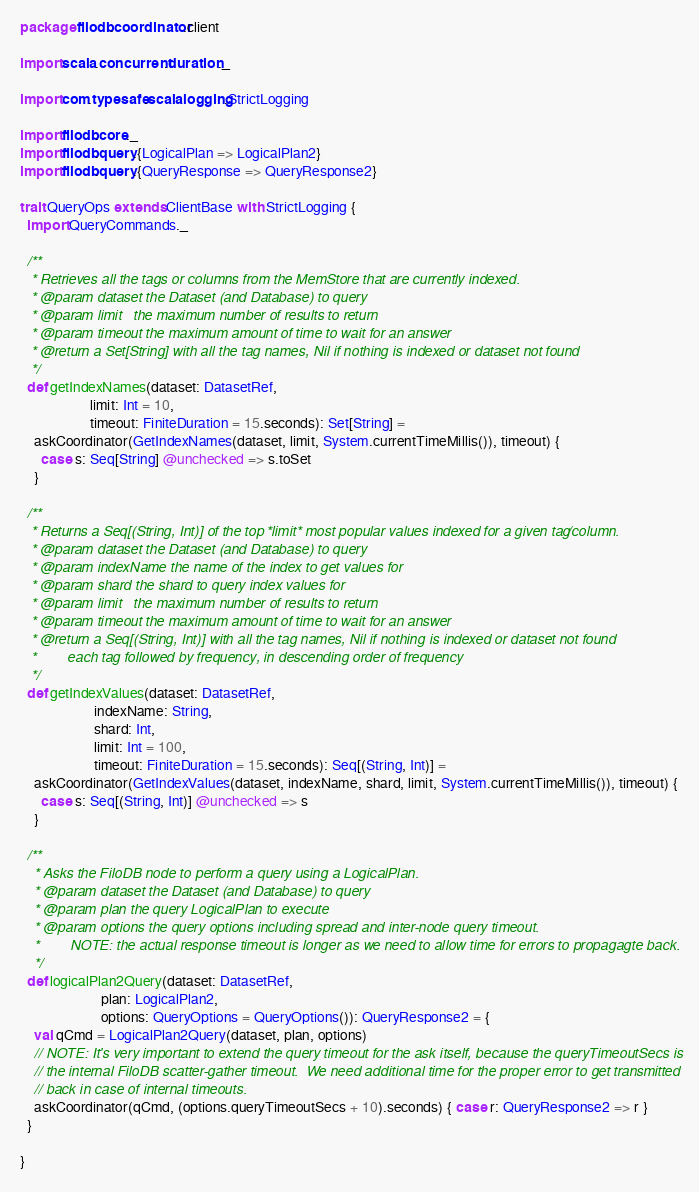Convert code to text. <code><loc_0><loc_0><loc_500><loc_500><_Scala_>package filodb.coordinator.client

import scala.concurrent.duration._

import com.typesafe.scalalogging.StrictLogging

import filodb.core._
import filodb.query.{LogicalPlan => LogicalPlan2}
import filodb.query.{QueryResponse => QueryResponse2}

trait QueryOps extends ClientBase with StrictLogging {
  import QueryCommands._

  /**
   * Retrieves all the tags or columns from the MemStore that are currently indexed.
   * @param dataset the Dataset (and Database) to query
   * @param limit   the maximum number of results to return
   * @param timeout the maximum amount of time to wait for an answer
   * @return a Set[String] with all the tag names, Nil if nothing is indexed or dataset not found
   */
  def getIndexNames(dataset: DatasetRef,
                    limit: Int = 10,
                    timeout: FiniteDuration = 15.seconds): Set[String] =
    askCoordinator(GetIndexNames(dataset, limit, System.currentTimeMillis()), timeout) {
      case s: Seq[String] @unchecked => s.toSet
    }

  /**
   * Returns a Seq[(String, Int)] of the top *limit* most popular values indexed for a given tag/column.
   * @param dataset the Dataset (and Database) to query
   * @param indexName the name of the index to get values for
   * @param shard the shard to query index values for
   * @param limit   the maximum number of results to return
   * @param timeout the maximum amount of time to wait for an answer
   * @return a Seq[(String, Int)] with all the tag names, Nil if nothing is indexed or dataset not found
   *        each tag followed by frequency, in descending order of frequency
   */
  def getIndexValues(dataset: DatasetRef,
                     indexName: String,
                     shard: Int,
                     limit: Int = 100,
                     timeout: FiniteDuration = 15.seconds): Seq[(String, Int)] =
    askCoordinator(GetIndexValues(dataset, indexName, shard, limit, System.currentTimeMillis()), timeout) {
      case s: Seq[(String, Int)] @unchecked => s
    }

  /**
    * Asks the FiloDB node to perform a query using a LogicalPlan.
    * @param dataset the Dataset (and Database) to query
    * @param plan the query LogicalPlan to execute
    * @param options the query options including spread and inter-node query timeout.
    *        NOTE: the actual response timeout is longer as we need to allow time for errors to propagagte back.
    */
  def logicalPlan2Query(dataset: DatasetRef,
                       plan: LogicalPlan2,
                       options: QueryOptions = QueryOptions()): QueryResponse2 = {
    val qCmd = LogicalPlan2Query(dataset, plan, options)
    // NOTE: It's very important to extend the query timeout for the ask itself, because the queryTimeoutSecs is
    // the internal FiloDB scatter-gather timeout.  We need additional time for the proper error to get transmitted
    // back in case of internal timeouts.
    askCoordinator(qCmd, (options.queryTimeoutSecs + 10).seconds) { case r: QueryResponse2 => r }
  }

}</code> 